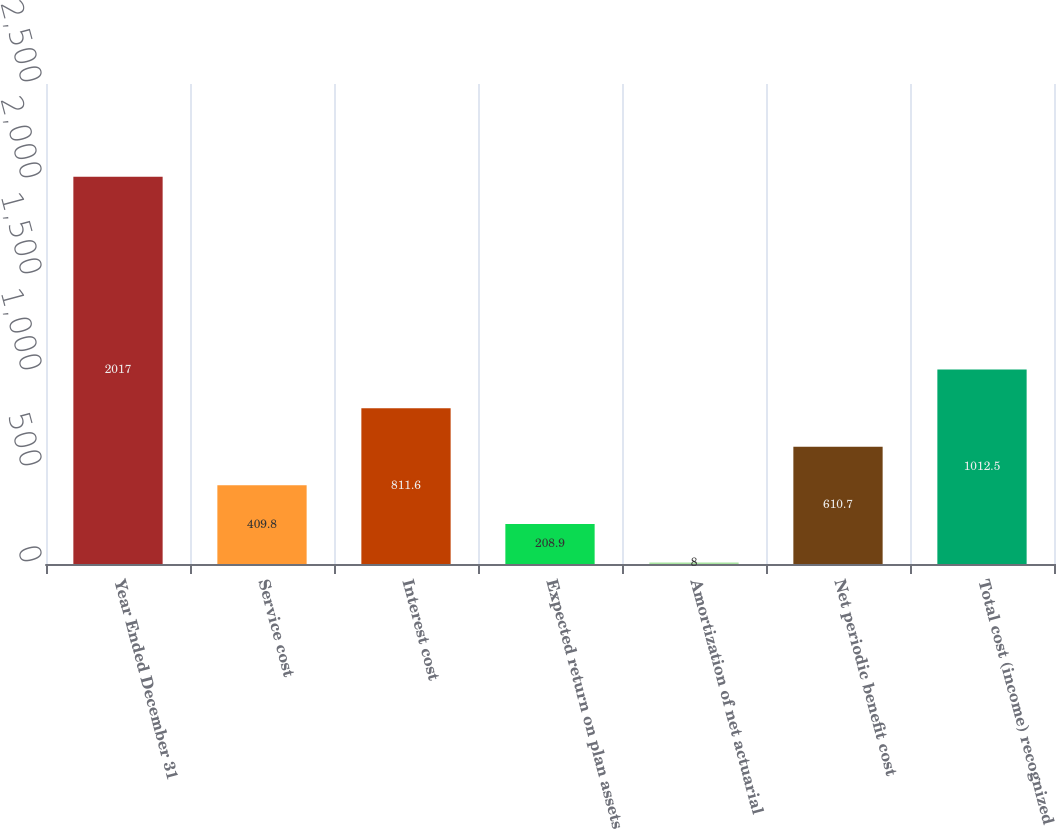<chart> <loc_0><loc_0><loc_500><loc_500><bar_chart><fcel>Year Ended December 31<fcel>Service cost<fcel>Interest cost<fcel>Expected return on plan assets<fcel>Amortization of net actuarial<fcel>Net periodic benefit cost<fcel>Total cost (income) recognized<nl><fcel>2017<fcel>409.8<fcel>811.6<fcel>208.9<fcel>8<fcel>610.7<fcel>1012.5<nl></chart> 